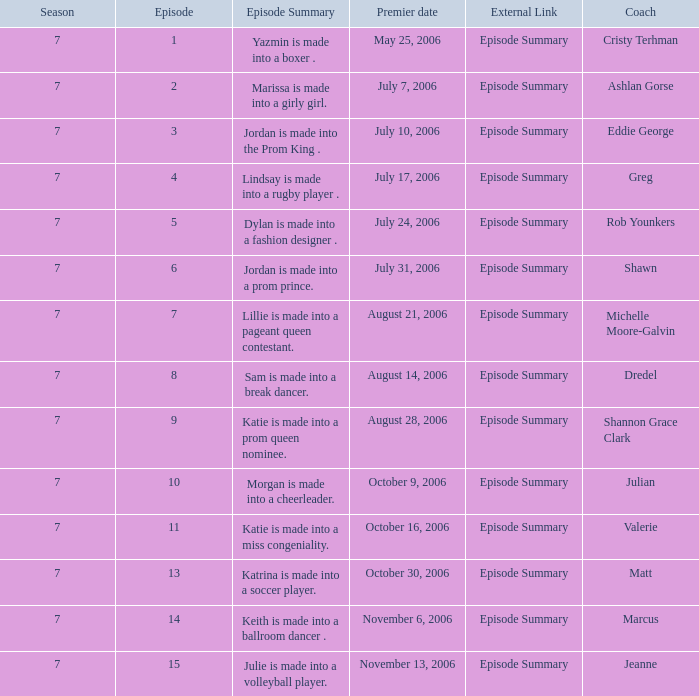What is the outline of episode 15? Julie is made into a volleyball player. 